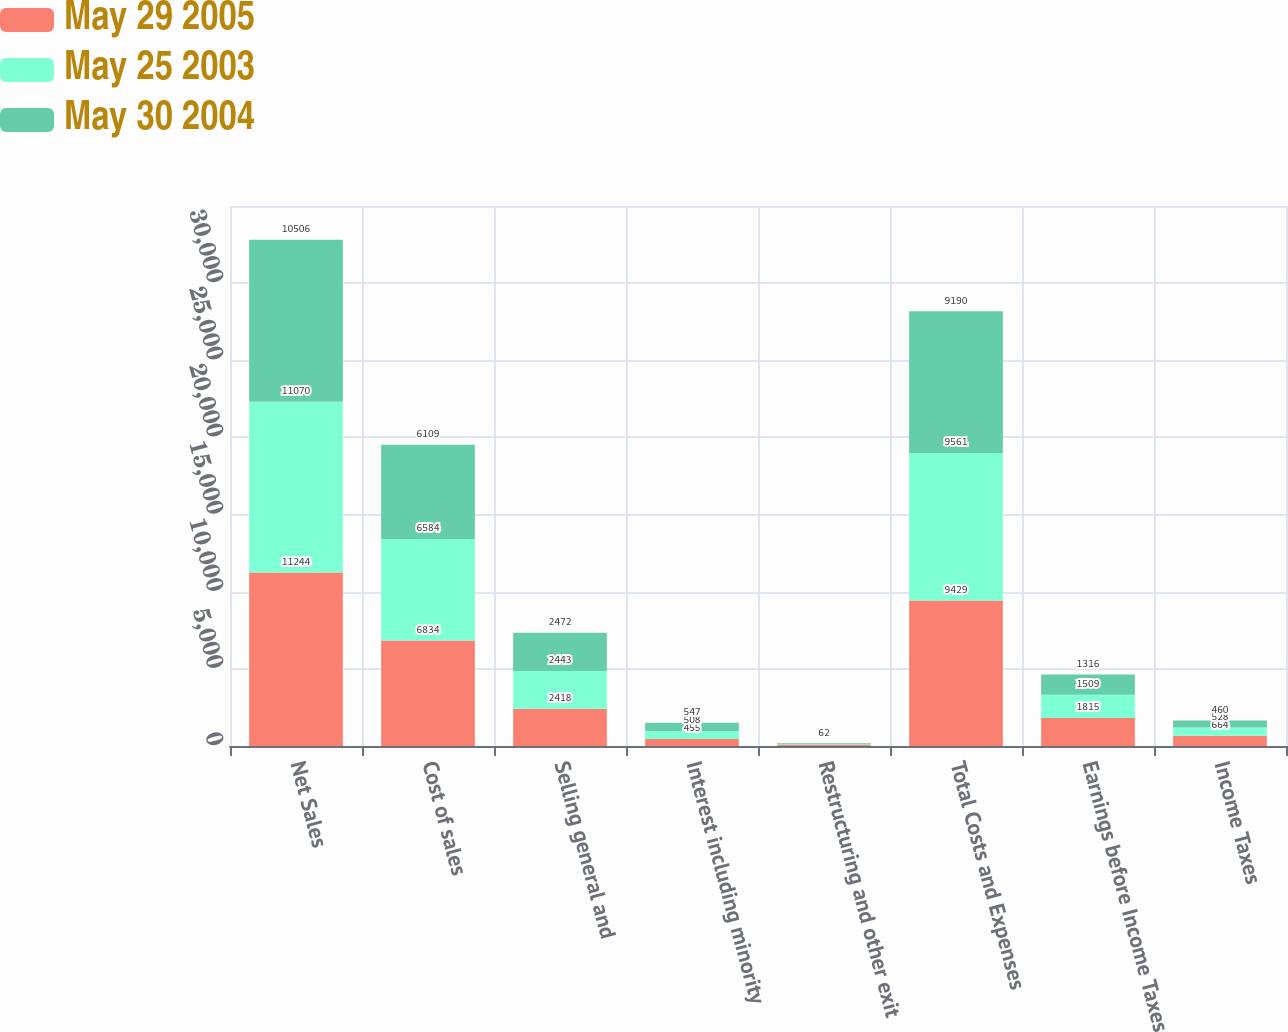Convert chart. <chart><loc_0><loc_0><loc_500><loc_500><stacked_bar_chart><ecel><fcel>Net Sales<fcel>Cost of sales<fcel>Selling general and<fcel>Interest including minority<fcel>Restructuring and other exit<fcel>Total Costs and Expenses<fcel>Earnings before Income Taxes<fcel>Income Taxes<nl><fcel>May 29 2005<fcel>11244<fcel>6834<fcel>2418<fcel>455<fcel>84<fcel>9429<fcel>1815<fcel>664<nl><fcel>May 25 2003<fcel>11070<fcel>6584<fcel>2443<fcel>508<fcel>26<fcel>9561<fcel>1509<fcel>528<nl><fcel>May 30 2004<fcel>10506<fcel>6109<fcel>2472<fcel>547<fcel>62<fcel>9190<fcel>1316<fcel>460<nl></chart> 